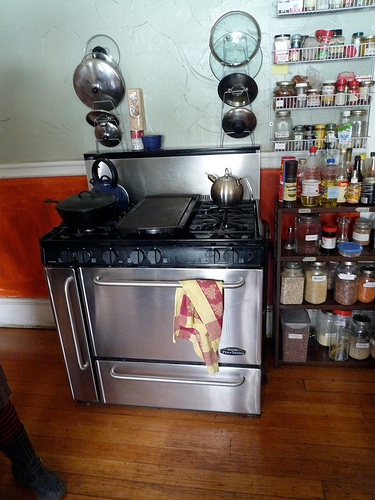Describe the objects in this image and their specific colors. I can see oven in lightblue, black, gray, darkgray, and lightgray tones, bottle in lightblue, black, darkgray, gray, and lightgray tones, bottle in lightblue, gray, maroon, and black tones, bottle in lightblue, gray, black, and darkgray tones, and bottle in lightblue, tan, black, and gray tones in this image. 